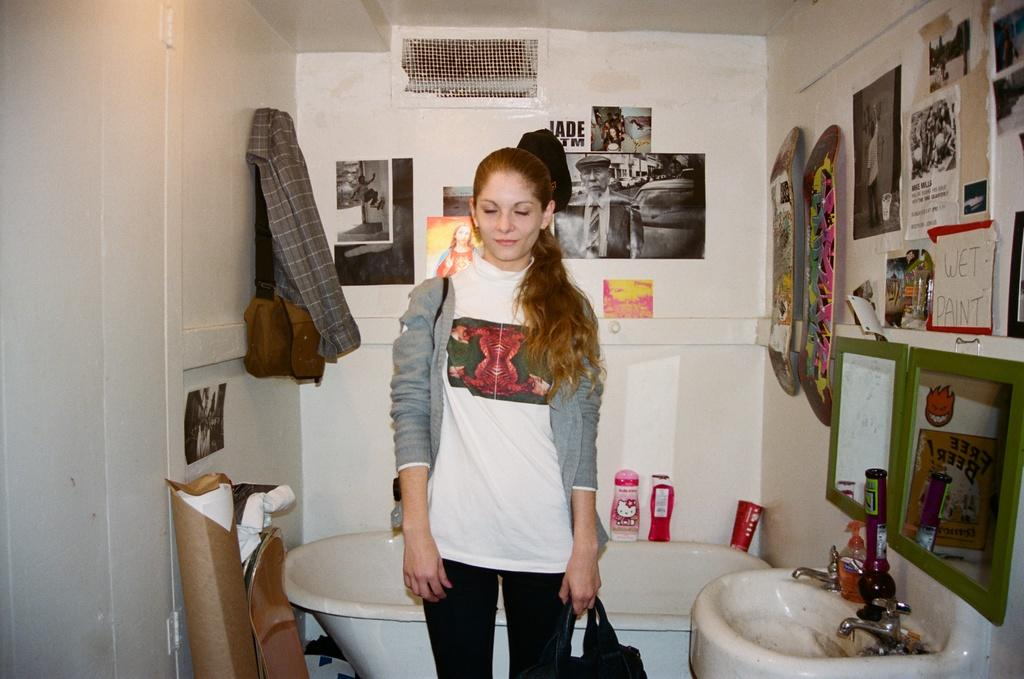What is the main subject in the image? There is a woman standing in the image. What can be seen in the background of the image? There is a hand wash basin and a bathtub in the image. What is visible on the walls in the image? The walls have photos and posters on them. What might be used for personal hygiene in the image? The hand wash basin can be used for personal hygiene. What type of society is depicted in the image? There is no specific society depicted in the image; it shows a woman, a hand wash basin, a bathtub, and decorations on the walls. Is there any motion or movement happening in the image? The image does not depict any motion or movement; it is a still image. 